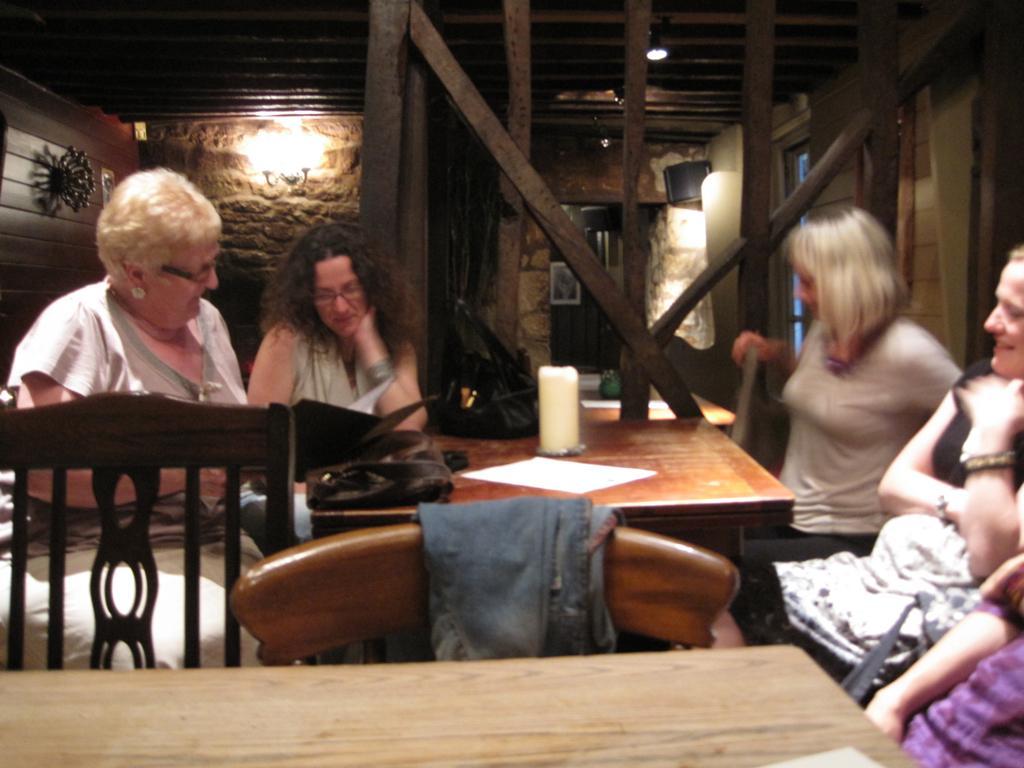In one or two sentences, can you explain what this image depicts? In this image I can see few women are sitting on chairs. I can also see two of them are wearing specs. Here on this table I can see a candle and few bags. I can also see few more chairs and a table. 